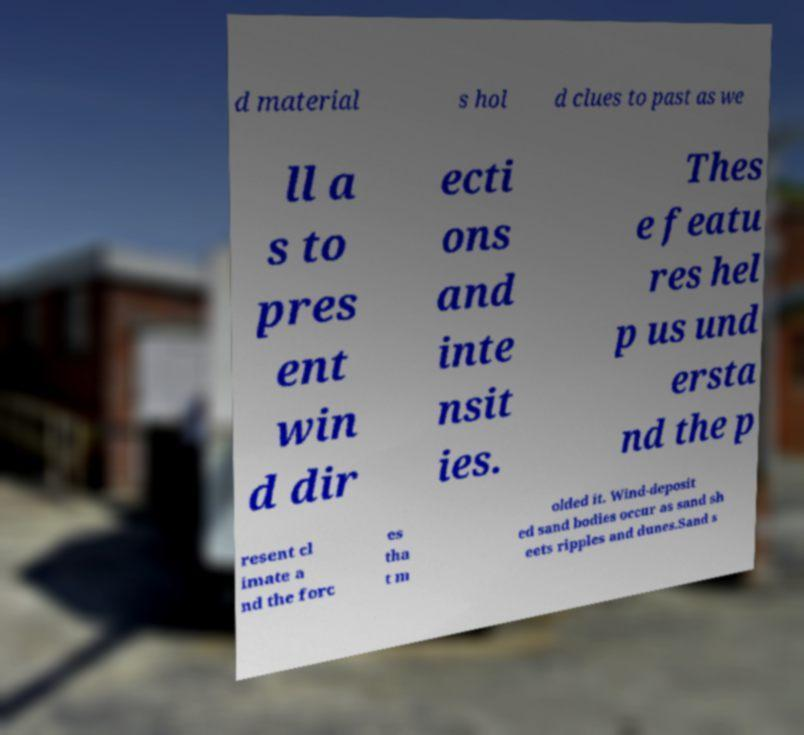For documentation purposes, I need the text within this image transcribed. Could you provide that? d material s hol d clues to past as we ll a s to pres ent win d dir ecti ons and inte nsit ies. Thes e featu res hel p us und ersta nd the p resent cl imate a nd the forc es tha t m olded it. Wind-deposit ed sand bodies occur as sand sh eets ripples and dunes.Sand s 